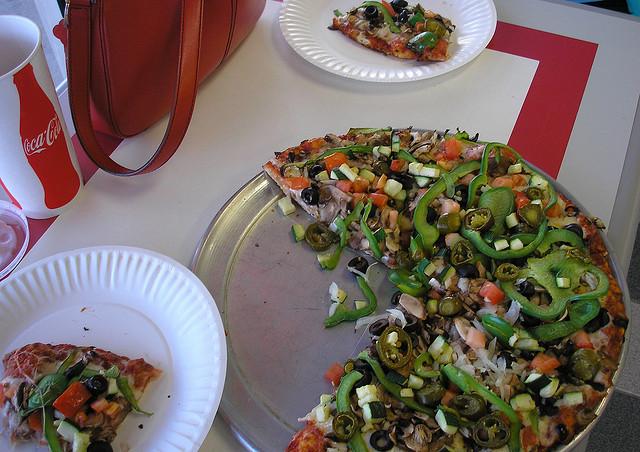What is the green topping on the pizza?
Be succinct. Pepper. What color are the plates?
Give a very brief answer. White. Are the plates disposable?
Answer briefly. Yes. 